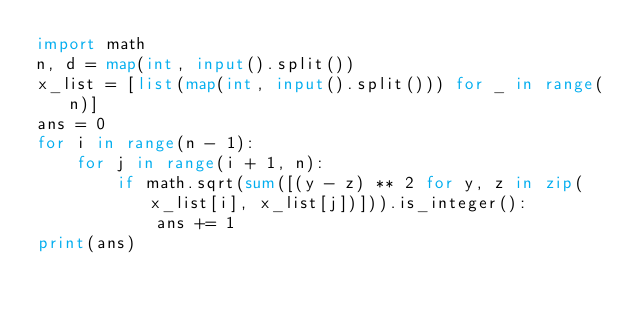Convert code to text. <code><loc_0><loc_0><loc_500><loc_500><_Python_>import math
n, d = map(int, input().split())
x_list = [list(map(int, input().split())) for _ in range(n)]
ans = 0
for i in range(n - 1):
    for j in range(i + 1, n):
        if math.sqrt(sum([(y - z) ** 2 for y, z in zip(x_list[i], x_list[j])])).is_integer():
            ans += 1
print(ans)</code> 